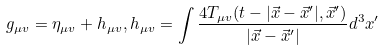<formula> <loc_0><loc_0><loc_500><loc_500>g _ { \mu v } = \eta _ { \mu v } + h _ { \mu v } , h _ { \mu v } = \int \frac { 4 T _ { \mu v } ( t - | \vec { x } - \vec { x } ^ { \prime } | , \vec { x } ^ { \prime } ) } { | \vec { x } - \vec { x } ^ { \prime } | } d ^ { 3 } x ^ { \prime }</formula> 